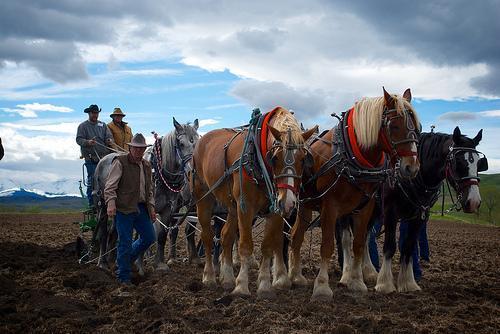How many horses are black?
Give a very brief answer. 1. 